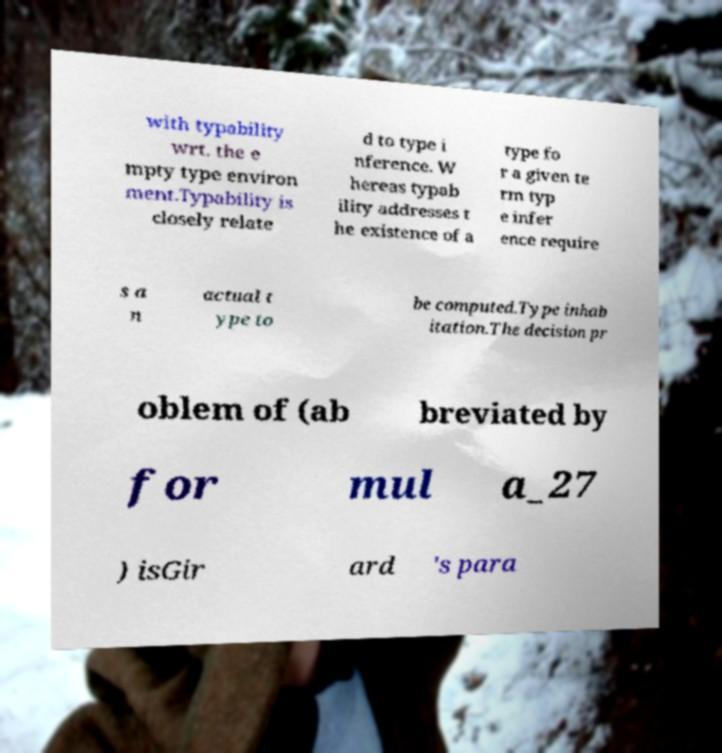Can you read and provide the text displayed in the image?This photo seems to have some interesting text. Can you extract and type it out for me? with typability wrt. the e mpty type environ ment.Typability is closely relate d to type i nference. W hereas typab ility addresses t he existence of a type fo r a given te rm typ e infer ence require s a n actual t ype to be computed.Type inhab itation.The decision pr oblem of (ab breviated by for mul a_27 ) isGir ard 's para 